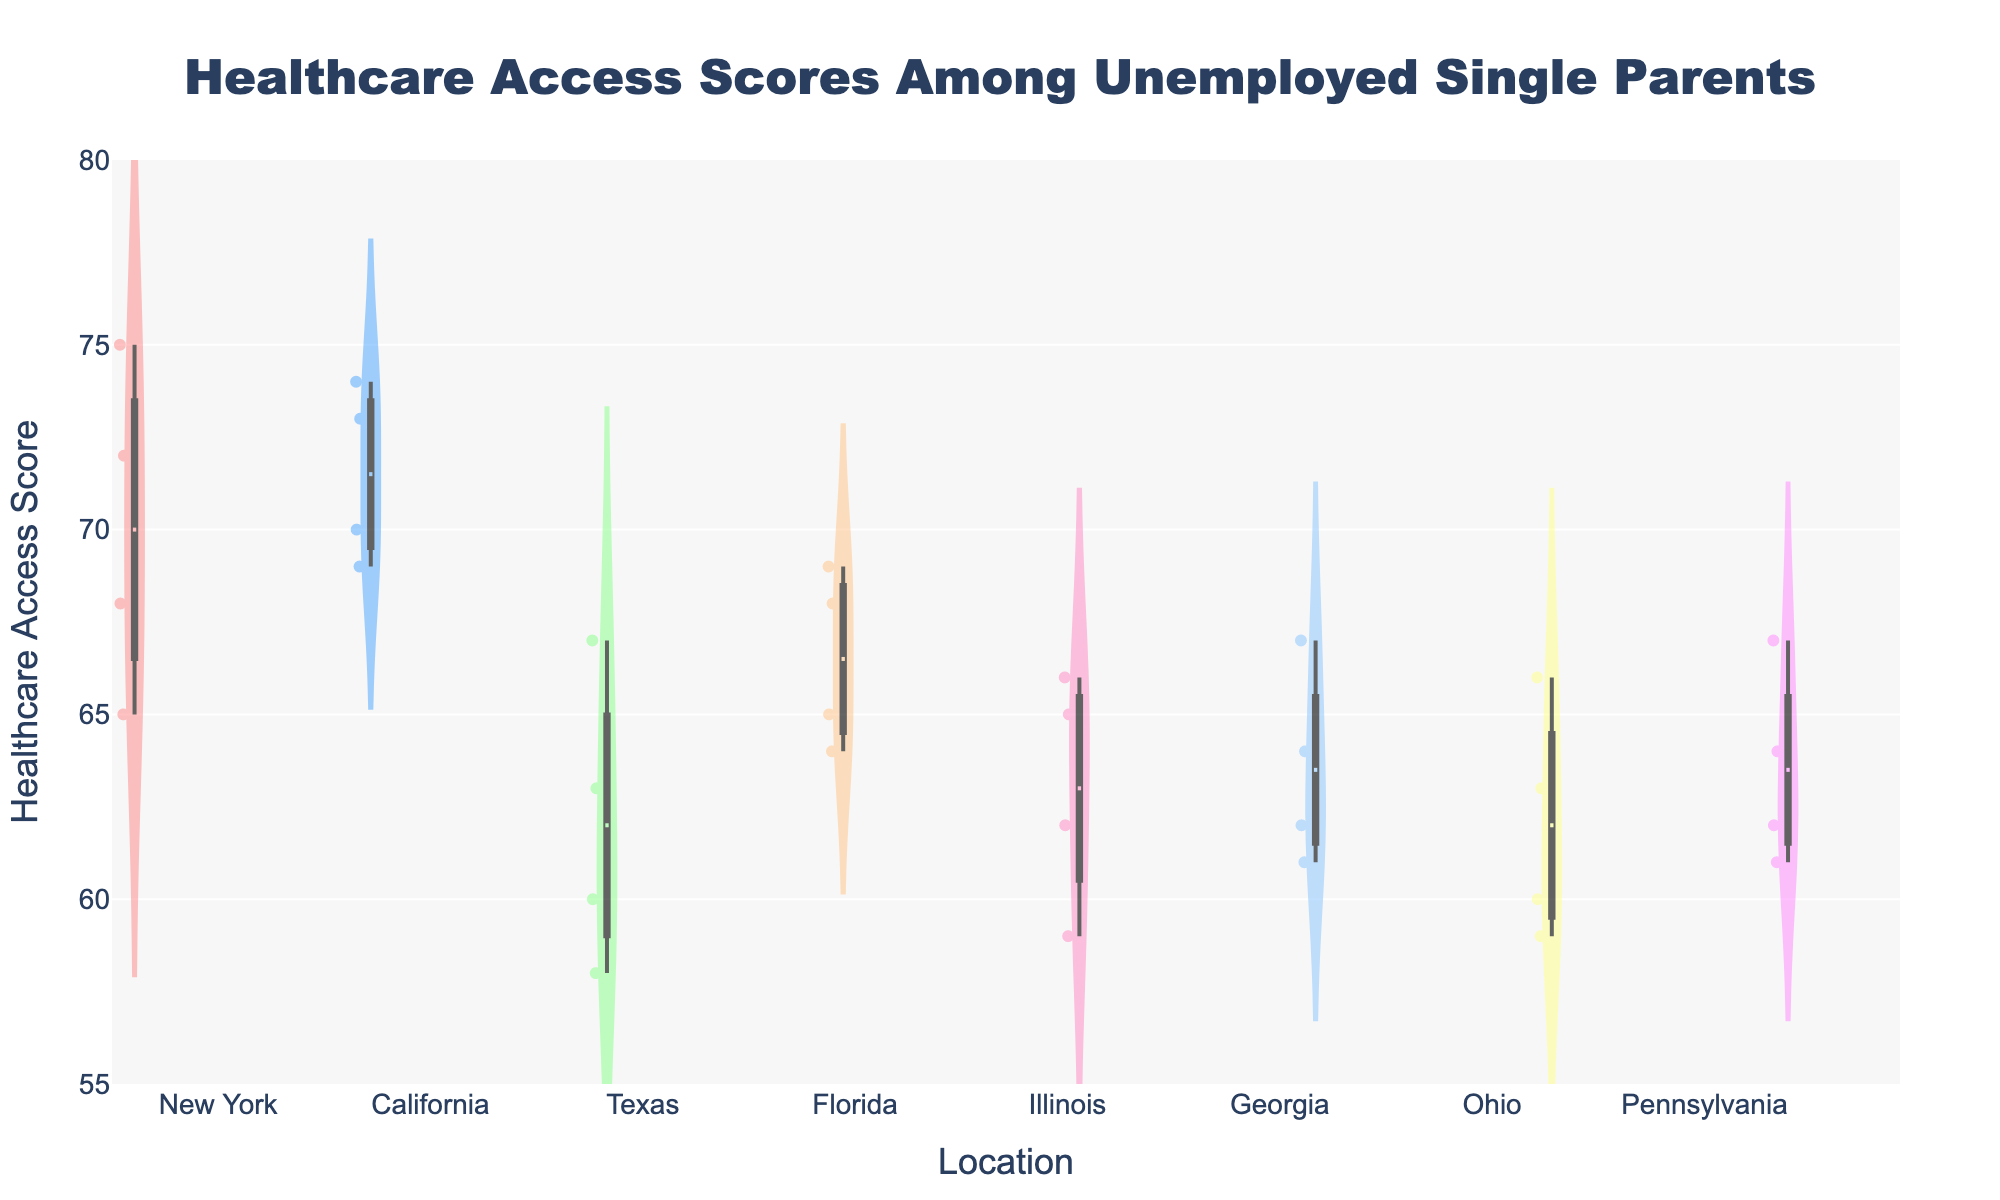What is the title of the chart? The title of the chart is displayed at the top and reads "Healthcare Access Scores Among Unemployed Single Parents".
Answer: Healthcare Access Scores Among Unemployed Single Parents What is the range of the y-axis? The range of the y-axis can be seen on the left side of the chart and spans from 55 to 80.
Answer: 55 to 80 How are the data points represented in the chart? The data points are represented by dots within the violin plots. They show individual healthcare access scores for each location.
Answer: By dots within the violin plots Which location has the widest distribution of healthcare access scores? By looking at the width of the violins, Texas has the widest distribution because its violin plot is visibly broader compared to other locations.
Answer: Texas What is the healthcare access score with the highest density for Georgia? The area of highest density in a violin plot is where the plot is the widest. For Georgia, this appears to be around a score of 62 to 64.
Answer: 62 to 64 Which location has the lowest median healthcare access score? The median is represented by the white line within the box plot overlays. Texas has the lowest median healthcare access score.
Answer: Texas What is the mean healthcare access score for California? The mean is represented by a dashed line within the violin plot. For California, the mean score line is at approximately 71.5.
Answer: 71.5 Compare the median healthcare access scores of Ohio and Pennsylvania. Which is higher? The median is again represented by the white line in the box plot. Pennsylvania's median appears slightly higher than Ohio's.
Answer: Pennsylvania How does the variability of healthcare access scores in New York compare to that in Illinois? Variability can be understood by the interquartile range (box length). New York's box plot is longer, indicating higher variability compared to Illinois.
Answer: New York has higher variability What does the box plot within each violin plot represent? The box plot shows the interquartile range (IQR) with a white line representing the median, and it includes whiskers that generally extend to the regions excluding outliers.
Answer: IQR and median with whiskers How many locations are represented in the chart? By counting the number of distinct violin plots, we see there are 7 locations represented.
Answer: 7 